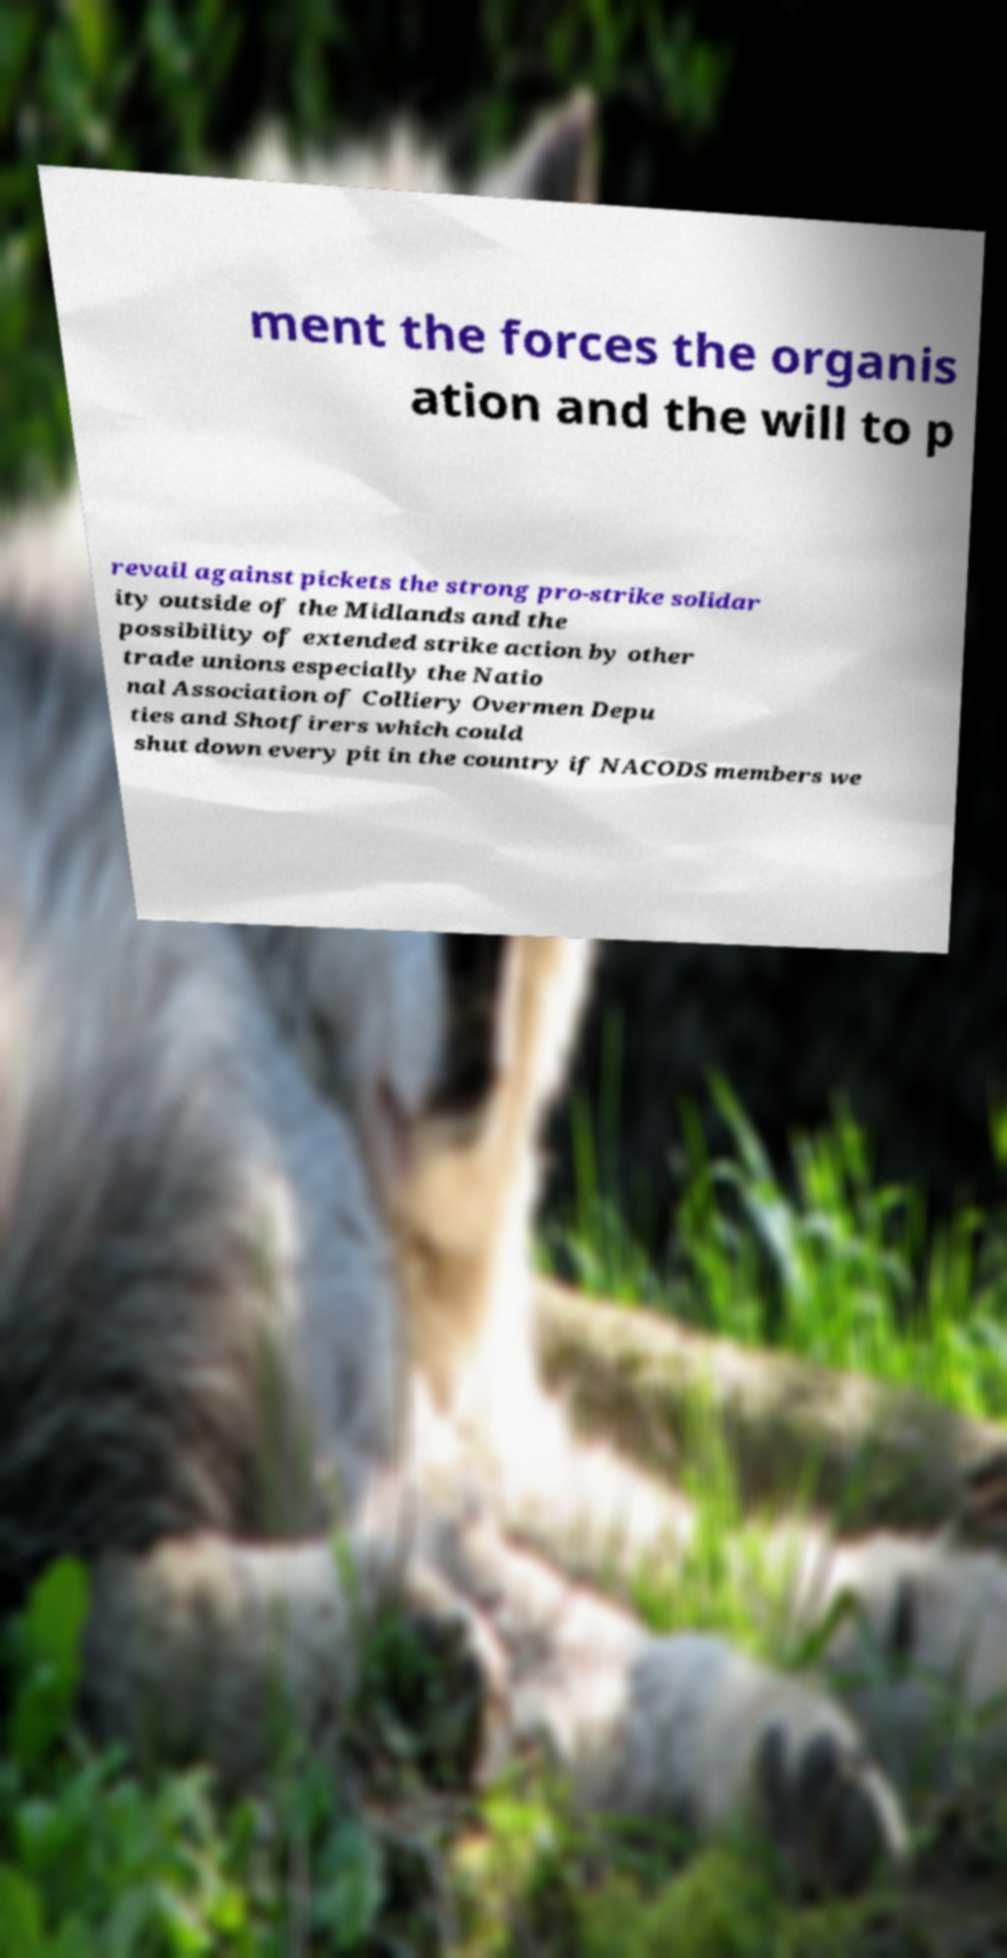Please identify and transcribe the text found in this image. ment the forces the organis ation and the will to p revail against pickets the strong pro-strike solidar ity outside of the Midlands and the possibility of extended strike action by other trade unions especially the Natio nal Association of Colliery Overmen Depu ties and Shotfirers which could shut down every pit in the country if NACODS members we 